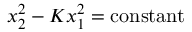Convert formula to latex. <formula><loc_0><loc_0><loc_500><loc_500>x _ { 2 } ^ { 2 } - K x _ { 1 } ^ { 2 } = c o n s t a n t</formula> 